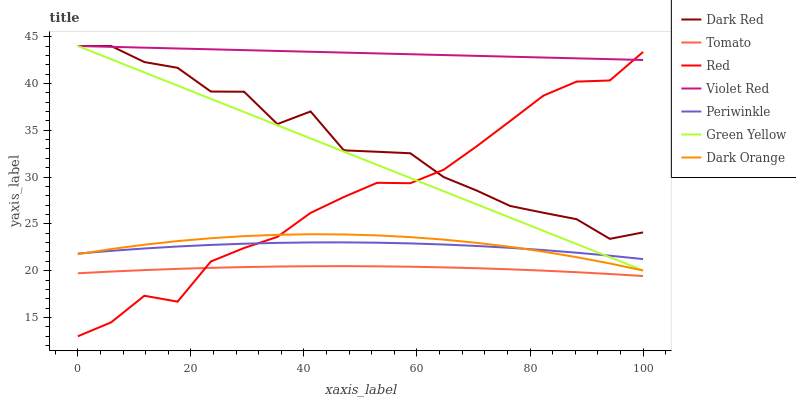Does Tomato have the minimum area under the curve?
Answer yes or no. Yes. Does Violet Red have the maximum area under the curve?
Answer yes or no. Yes. Does Dark Orange have the minimum area under the curve?
Answer yes or no. No. Does Dark Orange have the maximum area under the curve?
Answer yes or no. No. Is Violet Red the smoothest?
Answer yes or no. Yes. Is Dark Red the roughest?
Answer yes or no. Yes. Is Dark Orange the smoothest?
Answer yes or no. No. Is Dark Orange the roughest?
Answer yes or no. No. Does Red have the lowest value?
Answer yes or no. Yes. Does Dark Orange have the lowest value?
Answer yes or no. No. Does Green Yellow have the highest value?
Answer yes or no. Yes. Does Dark Orange have the highest value?
Answer yes or no. No. Is Dark Orange less than Dark Red?
Answer yes or no. Yes. Is Green Yellow greater than Tomato?
Answer yes or no. Yes. Does Dark Orange intersect Red?
Answer yes or no. Yes. Is Dark Orange less than Red?
Answer yes or no. No. Is Dark Orange greater than Red?
Answer yes or no. No. Does Dark Orange intersect Dark Red?
Answer yes or no. No. 